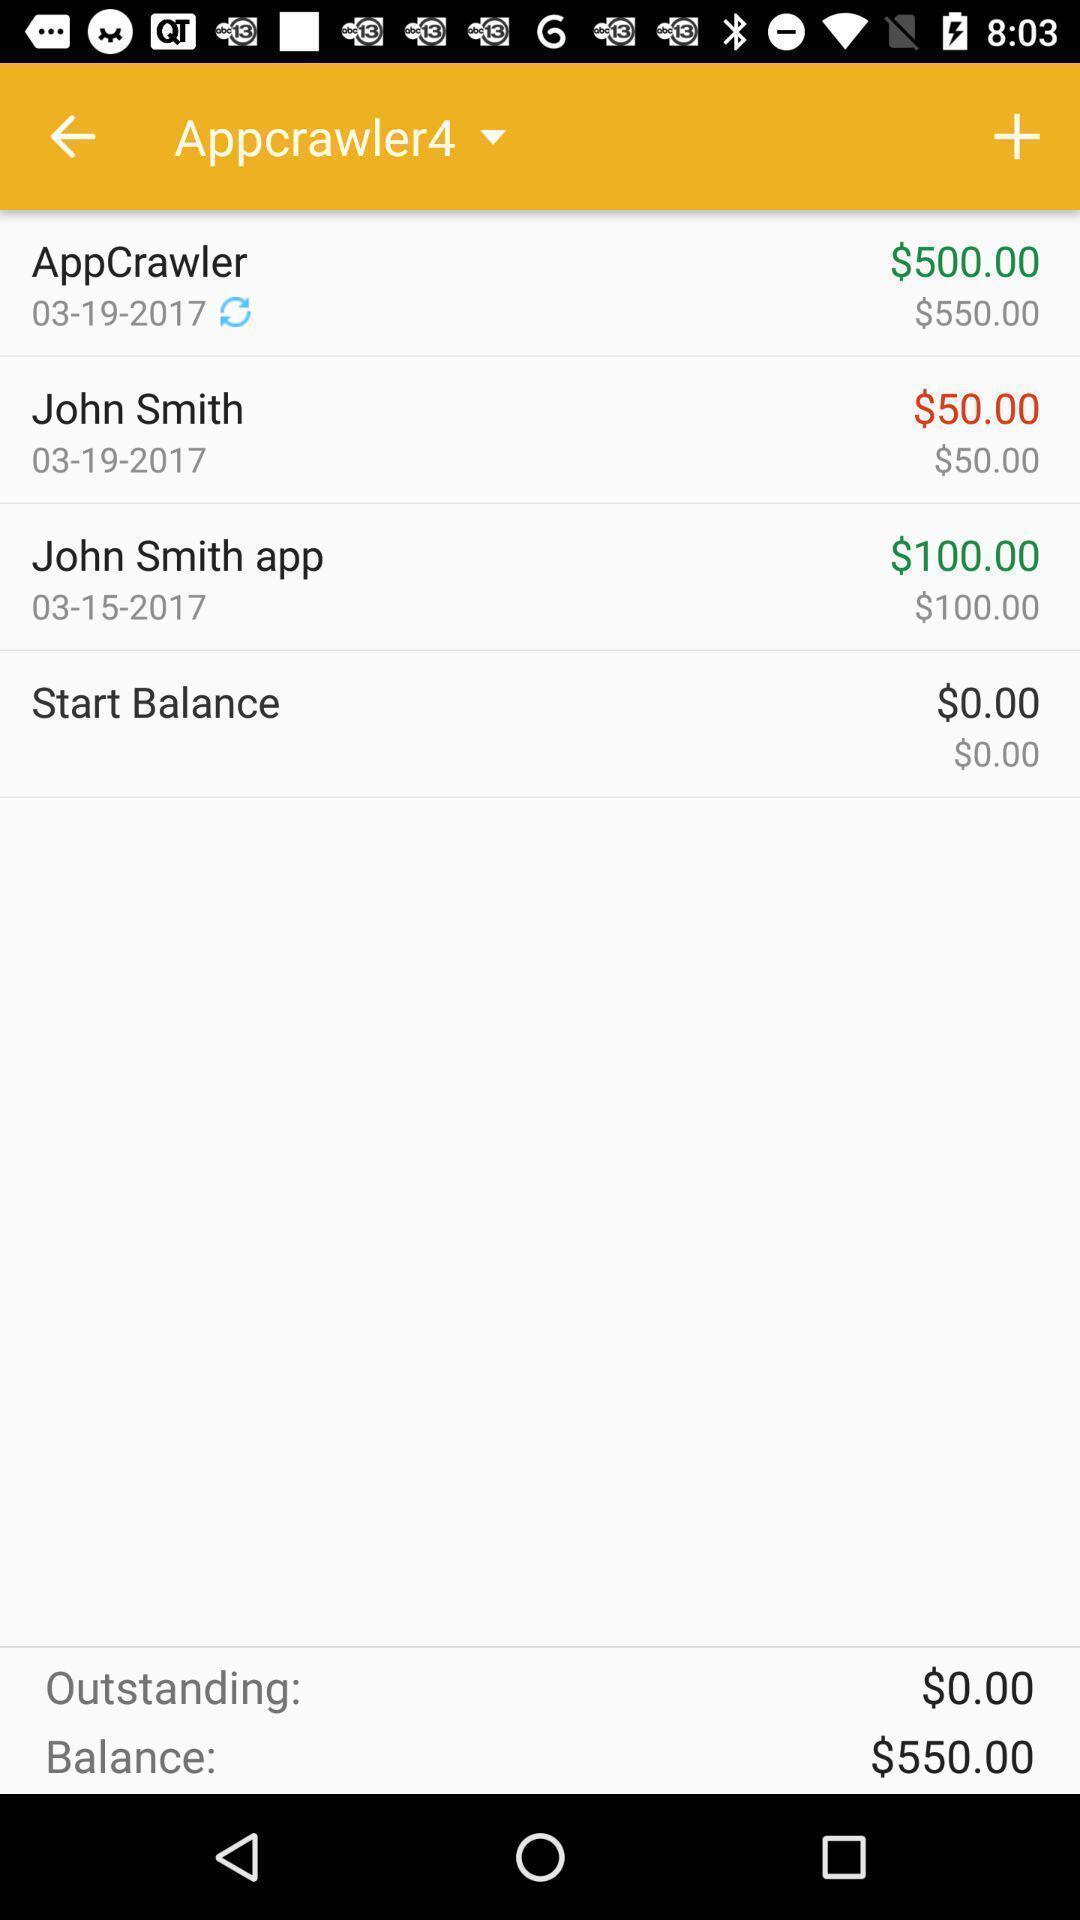Tell me what you see in this picture. Various transactions page displayed in a finances managing app. 